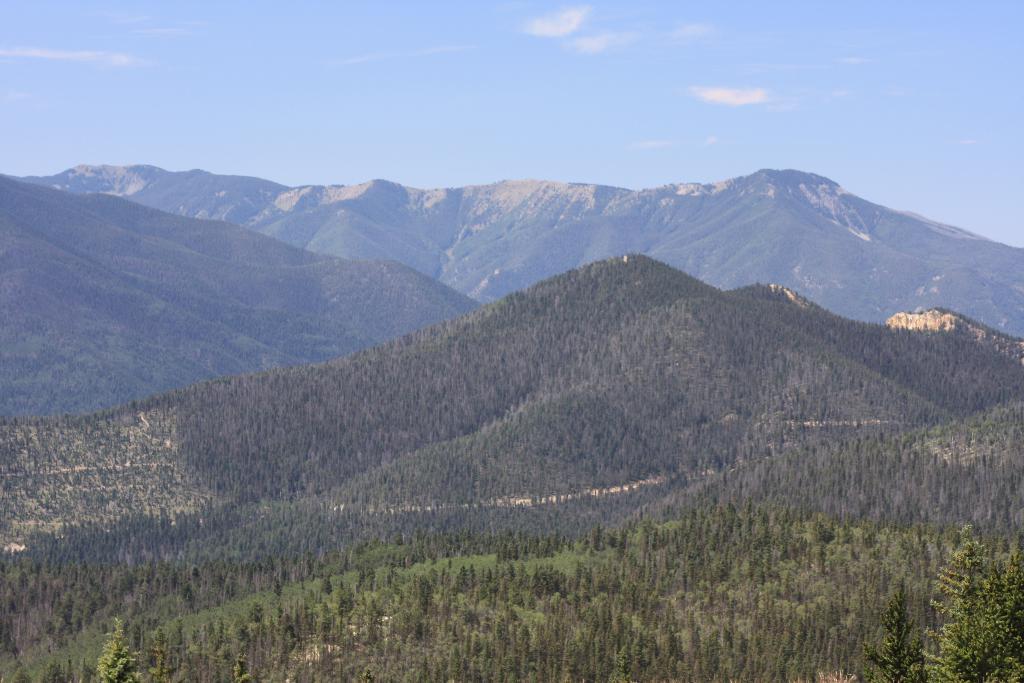Please provide a concise description of this image. In this image I can see many mountains, trees and in the background I can see the sky and clouds. 